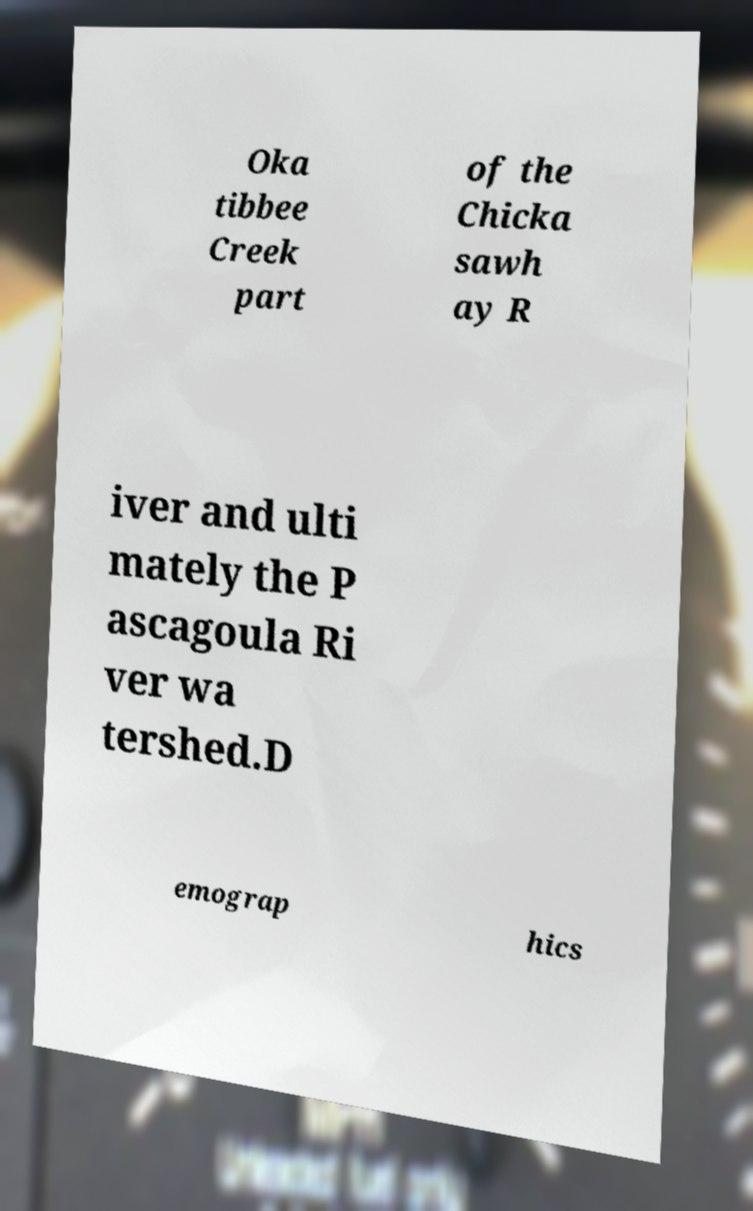Can you read and provide the text displayed in the image?This photo seems to have some interesting text. Can you extract and type it out for me? Oka tibbee Creek part of the Chicka sawh ay R iver and ulti mately the P ascagoula Ri ver wa tershed.D emograp hics 